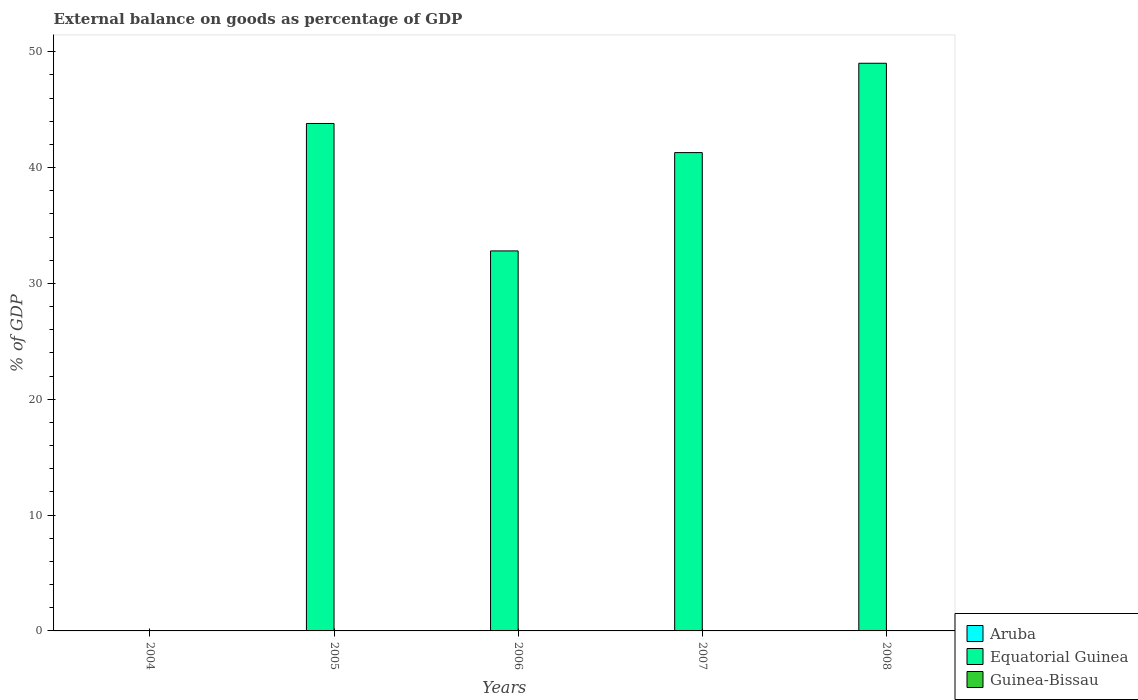How many bars are there on the 4th tick from the left?
Provide a succinct answer. 1. In how many cases, is the number of bars for a given year not equal to the number of legend labels?
Keep it short and to the point. 5. What is the external balance on goods as percentage of GDP in Aruba in 2007?
Offer a terse response. 0. Across all years, what is the maximum external balance on goods as percentage of GDP in Equatorial Guinea?
Your answer should be very brief. 49.01. What is the difference between the external balance on goods as percentage of GDP in Aruba in 2007 and the external balance on goods as percentage of GDP in Equatorial Guinea in 2005?
Keep it short and to the point. -43.81. What is the average external balance on goods as percentage of GDP in Guinea-Bissau per year?
Give a very brief answer. 0. What is the ratio of the external balance on goods as percentage of GDP in Equatorial Guinea in 2006 to that in 2007?
Give a very brief answer. 0.79. What is the difference between the highest and the second highest external balance on goods as percentage of GDP in Equatorial Guinea?
Make the answer very short. 5.2. What is the difference between the highest and the lowest external balance on goods as percentage of GDP in Equatorial Guinea?
Your response must be concise. 49.01. In how many years, is the external balance on goods as percentage of GDP in Aruba greater than the average external balance on goods as percentage of GDP in Aruba taken over all years?
Your answer should be compact. 0. Is it the case that in every year, the sum of the external balance on goods as percentage of GDP in Guinea-Bissau and external balance on goods as percentage of GDP in Aruba is greater than the external balance on goods as percentage of GDP in Equatorial Guinea?
Your response must be concise. No. How many bars are there?
Your response must be concise. 4. What is the difference between two consecutive major ticks on the Y-axis?
Provide a short and direct response. 10. Does the graph contain any zero values?
Offer a very short reply. Yes. How many legend labels are there?
Your answer should be compact. 3. How are the legend labels stacked?
Offer a terse response. Vertical. What is the title of the graph?
Offer a terse response. External balance on goods as percentage of GDP. Does "Nigeria" appear as one of the legend labels in the graph?
Your answer should be very brief. No. What is the label or title of the Y-axis?
Keep it short and to the point. % of GDP. What is the % of GDP in Equatorial Guinea in 2004?
Offer a terse response. 0. What is the % of GDP of Equatorial Guinea in 2005?
Offer a terse response. 43.81. What is the % of GDP of Aruba in 2006?
Offer a terse response. 0. What is the % of GDP in Equatorial Guinea in 2006?
Offer a terse response. 32.81. What is the % of GDP in Guinea-Bissau in 2006?
Make the answer very short. 0. What is the % of GDP of Equatorial Guinea in 2007?
Offer a terse response. 41.3. What is the % of GDP of Equatorial Guinea in 2008?
Offer a terse response. 49.01. Across all years, what is the maximum % of GDP of Equatorial Guinea?
Your answer should be compact. 49.01. What is the total % of GDP in Equatorial Guinea in the graph?
Offer a terse response. 166.92. What is the difference between the % of GDP of Equatorial Guinea in 2005 and that in 2006?
Provide a succinct answer. 11. What is the difference between the % of GDP in Equatorial Guinea in 2005 and that in 2007?
Ensure brevity in your answer.  2.51. What is the difference between the % of GDP in Equatorial Guinea in 2005 and that in 2008?
Give a very brief answer. -5.2. What is the difference between the % of GDP in Equatorial Guinea in 2006 and that in 2007?
Your answer should be very brief. -8.49. What is the difference between the % of GDP in Equatorial Guinea in 2006 and that in 2008?
Provide a short and direct response. -16.2. What is the difference between the % of GDP of Equatorial Guinea in 2007 and that in 2008?
Offer a very short reply. -7.71. What is the average % of GDP of Aruba per year?
Your answer should be very brief. 0. What is the average % of GDP in Equatorial Guinea per year?
Your answer should be compact. 33.38. What is the average % of GDP of Guinea-Bissau per year?
Your answer should be very brief. 0. What is the ratio of the % of GDP in Equatorial Guinea in 2005 to that in 2006?
Your response must be concise. 1.34. What is the ratio of the % of GDP of Equatorial Guinea in 2005 to that in 2007?
Offer a very short reply. 1.06. What is the ratio of the % of GDP of Equatorial Guinea in 2005 to that in 2008?
Offer a very short reply. 0.89. What is the ratio of the % of GDP in Equatorial Guinea in 2006 to that in 2007?
Provide a short and direct response. 0.79. What is the ratio of the % of GDP of Equatorial Guinea in 2006 to that in 2008?
Provide a succinct answer. 0.67. What is the ratio of the % of GDP of Equatorial Guinea in 2007 to that in 2008?
Offer a very short reply. 0.84. What is the difference between the highest and the second highest % of GDP in Equatorial Guinea?
Your answer should be very brief. 5.2. What is the difference between the highest and the lowest % of GDP of Equatorial Guinea?
Your answer should be compact. 49.01. 